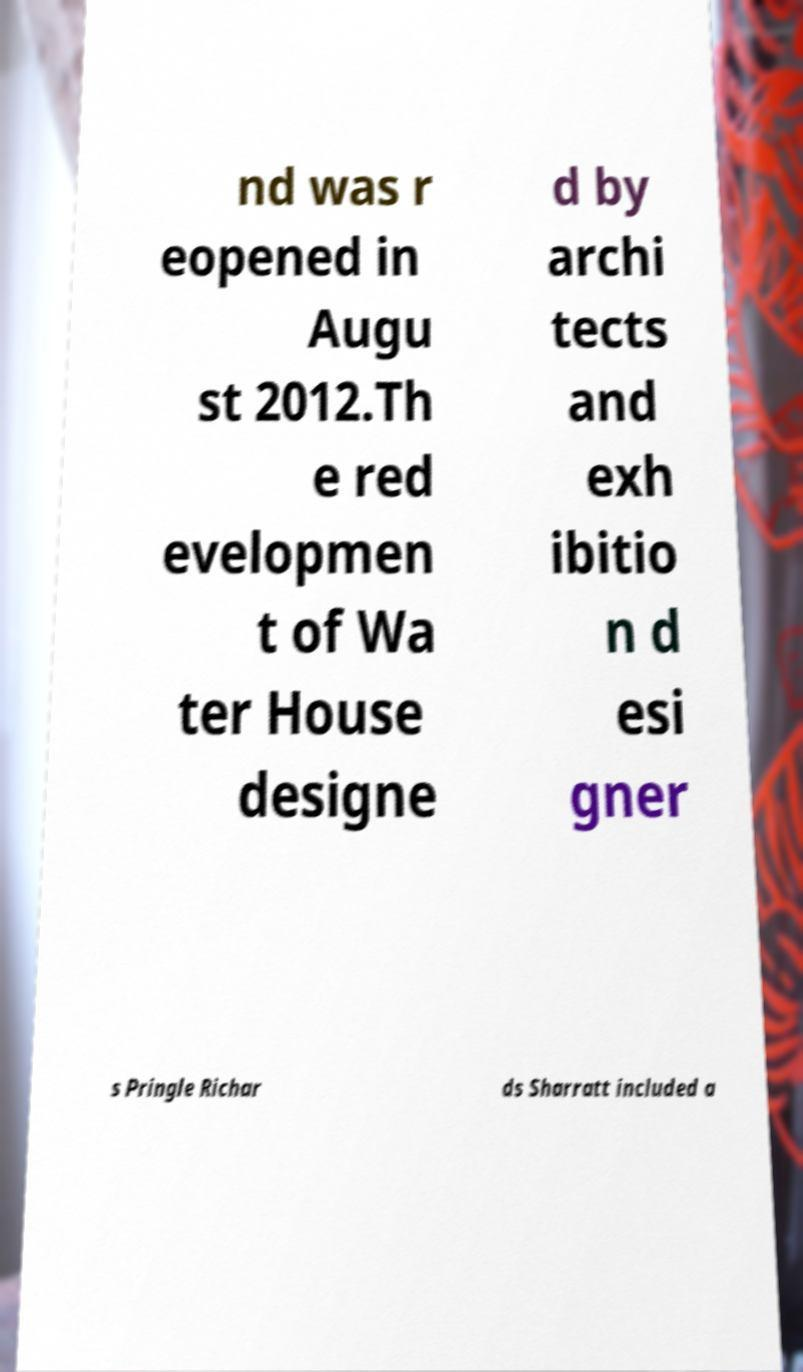I need the written content from this picture converted into text. Can you do that? nd was r eopened in Augu st 2012.Th e red evelopmen t of Wa ter House designe d by archi tects and exh ibitio n d esi gner s Pringle Richar ds Sharratt included a 